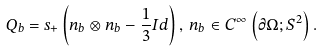Convert formula to latex. <formula><loc_0><loc_0><loc_500><loc_500>Q _ { b } = s _ { + } \left ( n _ { b } \otimes n _ { b } - \frac { 1 } { 3 } I d \right ) , \, n _ { b } \in C ^ { \infty } \left ( \partial \Omega ; S ^ { 2 } \right ) .</formula> 